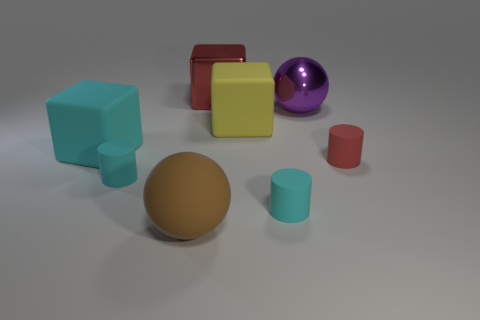Add 1 large cyan matte blocks. How many objects exist? 9 Subtract all cylinders. How many objects are left? 5 Subtract all large shiny cubes. Subtract all large blocks. How many objects are left? 4 Add 4 balls. How many balls are left? 6 Add 4 big yellow rubber blocks. How many big yellow rubber blocks exist? 5 Subtract 1 cyan cubes. How many objects are left? 7 